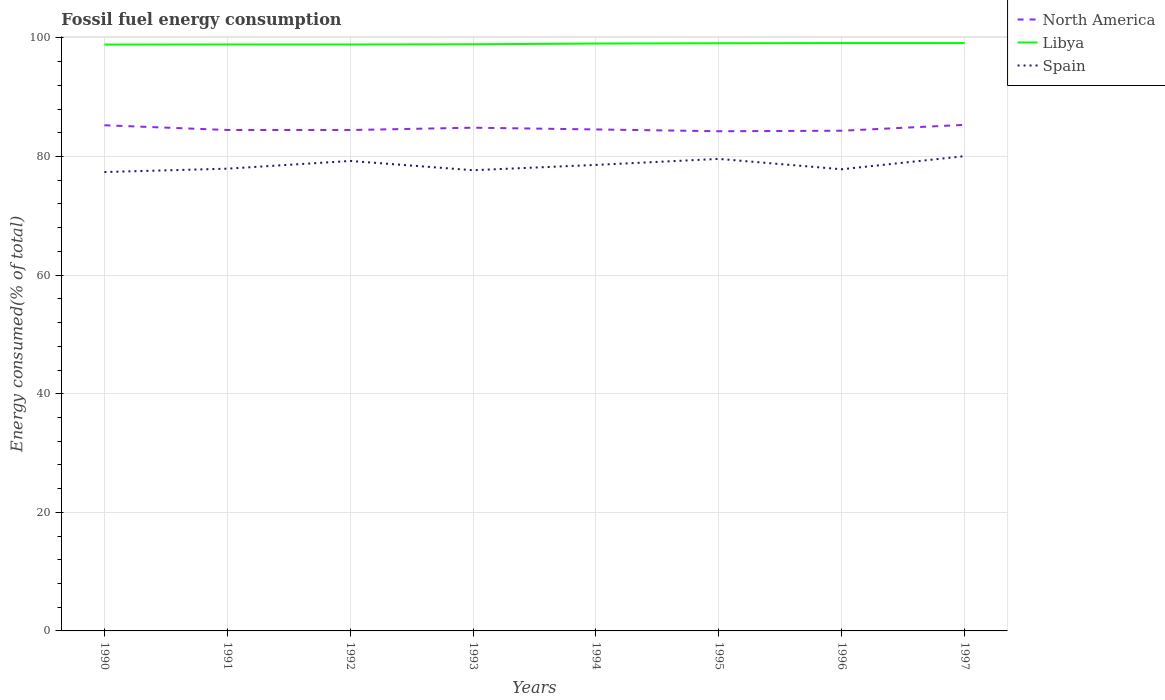How many different coloured lines are there?
Offer a very short reply. 3. Is the number of lines equal to the number of legend labels?
Offer a terse response. Yes. Across all years, what is the maximum percentage of energy consumed in Spain?
Give a very brief answer. 77.39. In which year was the percentage of energy consumed in Spain maximum?
Provide a short and direct response. 1990. What is the total percentage of energy consumed in Spain in the graph?
Keep it short and to the point. -0.9. What is the difference between the highest and the second highest percentage of energy consumed in Spain?
Your response must be concise. 2.67. What is the difference between the highest and the lowest percentage of energy consumed in Spain?
Make the answer very short. 4. What is the difference between two consecutive major ticks on the Y-axis?
Provide a succinct answer. 20. Are the values on the major ticks of Y-axis written in scientific E-notation?
Provide a short and direct response. No. Does the graph contain grids?
Ensure brevity in your answer.  Yes. What is the title of the graph?
Your answer should be very brief. Fossil fuel energy consumption. Does "Trinidad and Tobago" appear as one of the legend labels in the graph?
Provide a succinct answer. No. What is the label or title of the X-axis?
Give a very brief answer. Years. What is the label or title of the Y-axis?
Your answer should be very brief. Energy consumed(% of total). What is the Energy consumed(% of total) of North America in 1990?
Your response must be concise. 85.27. What is the Energy consumed(% of total) of Libya in 1990?
Give a very brief answer. 98.88. What is the Energy consumed(% of total) in Spain in 1990?
Provide a succinct answer. 77.39. What is the Energy consumed(% of total) of North America in 1991?
Give a very brief answer. 84.48. What is the Energy consumed(% of total) in Libya in 1991?
Your response must be concise. 98.9. What is the Energy consumed(% of total) of Spain in 1991?
Give a very brief answer. 77.95. What is the Energy consumed(% of total) in North America in 1992?
Offer a terse response. 84.47. What is the Energy consumed(% of total) in Libya in 1992?
Your response must be concise. 98.89. What is the Energy consumed(% of total) in Spain in 1992?
Your response must be concise. 79.25. What is the Energy consumed(% of total) in North America in 1993?
Keep it short and to the point. 84.86. What is the Energy consumed(% of total) in Libya in 1993?
Give a very brief answer. 98.93. What is the Energy consumed(% of total) in Spain in 1993?
Give a very brief answer. 77.69. What is the Energy consumed(% of total) in North America in 1994?
Offer a terse response. 84.57. What is the Energy consumed(% of total) of Libya in 1994?
Offer a terse response. 99.05. What is the Energy consumed(% of total) of Spain in 1994?
Your response must be concise. 78.59. What is the Energy consumed(% of total) of North America in 1995?
Your response must be concise. 84.27. What is the Energy consumed(% of total) of Libya in 1995?
Offer a terse response. 99.11. What is the Energy consumed(% of total) in Spain in 1995?
Make the answer very short. 79.6. What is the Energy consumed(% of total) in North America in 1996?
Provide a short and direct response. 84.35. What is the Energy consumed(% of total) of Libya in 1996?
Give a very brief answer. 99.14. What is the Energy consumed(% of total) in Spain in 1996?
Your response must be concise. 77.85. What is the Energy consumed(% of total) of North America in 1997?
Provide a short and direct response. 85.34. What is the Energy consumed(% of total) of Libya in 1997?
Offer a terse response. 99.14. What is the Energy consumed(% of total) in Spain in 1997?
Provide a short and direct response. 80.06. Across all years, what is the maximum Energy consumed(% of total) of North America?
Provide a succinct answer. 85.34. Across all years, what is the maximum Energy consumed(% of total) in Libya?
Ensure brevity in your answer.  99.14. Across all years, what is the maximum Energy consumed(% of total) of Spain?
Ensure brevity in your answer.  80.06. Across all years, what is the minimum Energy consumed(% of total) in North America?
Make the answer very short. 84.27. Across all years, what is the minimum Energy consumed(% of total) in Libya?
Provide a short and direct response. 98.88. Across all years, what is the minimum Energy consumed(% of total) of Spain?
Your response must be concise. 77.39. What is the total Energy consumed(% of total) of North America in the graph?
Provide a succinct answer. 677.61. What is the total Energy consumed(% of total) in Libya in the graph?
Your answer should be very brief. 792.04. What is the total Energy consumed(% of total) in Spain in the graph?
Make the answer very short. 628.39. What is the difference between the Energy consumed(% of total) in North America in 1990 and that in 1991?
Keep it short and to the point. 0.79. What is the difference between the Energy consumed(% of total) in Libya in 1990 and that in 1991?
Provide a succinct answer. -0.02. What is the difference between the Energy consumed(% of total) of Spain in 1990 and that in 1991?
Keep it short and to the point. -0.57. What is the difference between the Energy consumed(% of total) in North America in 1990 and that in 1992?
Provide a succinct answer. 0.8. What is the difference between the Energy consumed(% of total) of Libya in 1990 and that in 1992?
Keep it short and to the point. -0.01. What is the difference between the Energy consumed(% of total) of Spain in 1990 and that in 1992?
Offer a terse response. -1.87. What is the difference between the Energy consumed(% of total) in North America in 1990 and that in 1993?
Offer a terse response. 0.41. What is the difference between the Energy consumed(% of total) of Libya in 1990 and that in 1993?
Keep it short and to the point. -0.05. What is the difference between the Energy consumed(% of total) in Spain in 1990 and that in 1993?
Offer a very short reply. -0.31. What is the difference between the Energy consumed(% of total) of North America in 1990 and that in 1994?
Your response must be concise. 0.7. What is the difference between the Energy consumed(% of total) in Libya in 1990 and that in 1994?
Give a very brief answer. -0.17. What is the difference between the Energy consumed(% of total) in Spain in 1990 and that in 1994?
Provide a short and direct response. -1.2. What is the difference between the Energy consumed(% of total) of North America in 1990 and that in 1995?
Your answer should be very brief. 1.01. What is the difference between the Energy consumed(% of total) in Libya in 1990 and that in 1995?
Provide a short and direct response. -0.23. What is the difference between the Energy consumed(% of total) of Spain in 1990 and that in 1995?
Offer a terse response. -2.21. What is the difference between the Energy consumed(% of total) of North America in 1990 and that in 1996?
Your answer should be compact. 0.92. What is the difference between the Energy consumed(% of total) of Libya in 1990 and that in 1996?
Your response must be concise. -0.26. What is the difference between the Energy consumed(% of total) in Spain in 1990 and that in 1996?
Keep it short and to the point. -0.47. What is the difference between the Energy consumed(% of total) of North America in 1990 and that in 1997?
Provide a short and direct response. -0.07. What is the difference between the Energy consumed(% of total) of Libya in 1990 and that in 1997?
Keep it short and to the point. -0.26. What is the difference between the Energy consumed(% of total) in Spain in 1990 and that in 1997?
Keep it short and to the point. -2.67. What is the difference between the Energy consumed(% of total) in North America in 1991 and that in 1992?
Give a very brief answer. 0.01. What is the difference between the Energy consumed(% of total) of Libya in 1991 and that in 1992?
Your answer should be compact. 0.01. What is the difference between the Energy consumed(% of total) of Spain in 1991 and that in 1992?
Provide a succinct answer. -1.3. What is the difference between the Energy consumed(% of total) in North America in 1991 and that in 1993?
Ensure brevity in your answer.  -0.38. What is the difference between the Energy consumed(% of total) of Libya in 1991 and that in 1993?
Your answer should be compact. -0.03. What is the difference between the Energy consumed(% of total) of Spain in 1991 and that in 1993?
Offer a terse response. 0.26. What is the difference between the Energy consumed(% of total) in North America in 1991 and that in 1994?
Offer a terse response. -0.09. What is the difference between the Energy consumed(% of total) in Libya in 1991 and that in 1994?
Make the answer very short. -0.16. What is the difference between the Energy consumed(% of total) in Spain in 1991 and that in 1994?
Give a very brief answer. -0.64. What is the difference between the Energy consumed(% of total) in North America in 1991 and that in 1995?
Ensure brevity in your answer.  0.21. What is the difference between the Energy consumed(% of total) of Libya in 1991 and that in 1995?
Your answer should be very brief. -0.21. What is the difference between the Energy consumed(% of total) of Spain in 1991 and that in 1995?
Give a very brief answer. -1.65. What is the difference between the Energy consumed(% of total) in North America in 1991 and that in 1996?
Offer a terse response. 0.13. What is the difference between the Energy consumed(% of total) in Libya in 1991 and that in 1996?
Keep it short and to the point. -0.25. What is the difference between the Energy consumed(% of total) in Spain in 1991 and that in 1996?
Your response must be concise. 0.1. What is the difference between the Energy consumed(% of total) in North America in 1991 and that in 1997?
Keep it short and to the point. -0.86. What is the difference between the Energy consumed(% of total) of Libya in 1991 and that in 1997?
Your answer should be compact. -0.24. What is the difference between the Energy consumed(% of total) in Spain in 1991 and that in 1997?
Offer a terse response. -2.11. What is the difference between the Energy consumed(% of total) in North America in 1992 and that in 1993?
Ensure brevity in your answer.  -0.39. What is the difference between the Energy consumed(% of total) of Libya in 1992 and that in 1993?
Ensure brevity in your answer.  -0.04. What is the difference between the Energy consumed(% of total) in Spain in 1992 and that in 1993?
Provide a short and direct response. 1.56. What is the difference between the Energy consumed(% of total) of North America in 1992 and that in 1994?
Make the answer very short. -0.1. What is the difference between the Energy consumed(% of total) of Libya in 1992 and that in 1994?
Offer a very short reply. -0.16. What is the difference between the Energy consumed(% of total) in Spain in 1992 and that in 1994?
Your answer should be compact. 0.66. What is the difference between the Energy consumed(% of total) in North America in 1992 and that in 1995?
Offer a terse response. 0.2. What is the difference between the Energy consumed(% of total) of Libya in 1992 and that in 1995?
Ensure brevity in your answer.  -0.22. What is the difference between the Energy consumed(% of total) of Spain in 1992 and that in 1995?
Provide a short and direct response. -0.35. What is the difference between the Energy consumed(% of total) of North America in 1992 and that in 1996?
Make the answer very short. 0.12. What is the difference between the Energy consumed(% of total) of Libya in 1992 and that in 1996?
Your answer should be very brief. -0.25. What is the difference between the Energy consumed(% of total) of Spain in 1992 and that in 1996?
Your response must be concise. 1.4. What is the difference between the Energy consumed(% of total) in North America in 1992 and that in 1997?
Offer a terse response. -0.87. What is the difference between the Energy consumed(% of total) of Libya in 1992 and that in 1997?
Offer a terse response. -0.25. What is the difference between the Energy consumed(% of total) of Spain in 1992 and that in 1997?
Make the answer very short. -0.81. What is the difference between the Energy consumed(% of total) in North America in 1993 and that in 1994?
Make the answer very short. 0.29. What is the difference between the Energy consumed(% of total) of Libya in 1993 and that in 1994?
Your response must be concise. -0.12. What is the difference between the Energy consumed(% of total) in Spain in 1993 and that in 1994?
Ensure brevity in your answer.  -0.9. What is the difference between the Energy consumed(% of total) of North America in 1993 and that in 1995?
Your answer should be very brief. 0.6. What is the difference between the Energy consumed(% of total) in Libya in 1993 and that in 1995?
Your answer should be very brief. -0.17. What is the difference between the Energy consumed(% of total) of Spain in 1993 and that in 1995?
Give a very brief answer. -1.91. What is the difference between the Energy consumed(% of total) in North America in 1993 and that in 1996?
Offer a terse response. 0.51. What is the difference between the Energy consumed(% of total) in Libya in 1993 and that in 1996?
Your answer should be very brief. -0.21. What is the difference between the Energy consumed(% of total) in Spain in 1993 and that in 1996?
Keep it short and to the point. -0.16. What is the difference between the Energy consumed(% of total) in North America in 1993 and that in 1997?
Make the answer very short. -0.48. What is the difference between the Energy consumed(% of total) in Libya in 1993 and that in 1997?
Provide a succinct answer. -0.21. What is the difference between the Energy consumed(% of total) in Spain in 1993 and that in 1997?
Your answer should be very brief. -2.37. What is the difference between the Energy consumed(% of total) in North America in 1994 and that in 1995?
Keep it short and to the point. 0.3. What is the difference between the Energy consumed(% of total) in Libya in 1994 and that in 1995?
Offer a terse response. -0.05. What is the difference between the Energy consumed(% of total) of Spain in 1994 and that in 1995?
Provide a short and direct response. -1.01. What is the difference between the Energy consumed(% of total) in North America in 1994 and that in 1996?
Give a very brief answer. 0.22. What is the difference between the Energy consumed(% of total) in Libya in 1994 and that in 1996?
Provide a short and direct response. -0.09. What is the difference between the Energy consumed(% of total) of Spain in 1994 and that in 1996?
Offer a terse response. 0.74. What is the difference between the Energy consumed(% of total) of North America in 1994 and that in 1997?
Make the answer very short. -0.77. What is the difference between the Energy consumed(% of total) of Libya in 1994 and that in 1997?
Your answer should be very brief. -0.08. What is the difference between the Energy consumed(% of total) of Spain in 1994 and that in 1997?
Give a very brief answer. -1.47. What is the difference between the Energy consumed(% of total) in North America in 1995 and that in 1996?
Offer a terse response. -0.08. What is the difference between the Energy consumed(% of total) of Libya in 1995 and that in 1996?
Offer a very short reply. -0.04. What is the difference between the Energy consumed(% of total) in Spain in 1995 and that in 1996?
Make the answer very short. 1.75. What is the difference between the Energy consumed(% of total) of North America in 1995 and that in 1997?
Your answer should be compact. -1.08. What is the difference between the Energy consumed(% of total) in Libya in 1995 and that in 1997?
Ensure brevity in your answer.  -0.03. What is the difference between the Energy consumed(% of total) in Spain in 1995 and that in 1997?
Your answer should be very brief. -0.46. What is the difference between the Energy consumed(% of total) of North America in 1996 and that in 1997?
Keep it short and to the point. -0.99. What is the difference between the Energy consumed(% of total) of Libya in 1996 and that in 1997?
Provide a short and direct response. 0. What is the difference between the Energy consumed(% of total) in Spain in 1996 and that in 1997?
Offer a terse response. -2.21. What is the difference between the Energy consumed(% of total) of North America in 1990 and the Energy consumed(% of total) of Libya in 1991?
Provide a succinct answer. -13.62. What is the difference between the Energy consumed(% of total) of North America in 1990 and the Energy consumed(% of total) of Spain in 1991?
Offer a terse response. 7.32. What is the difference between the Energy consumed(% of total) of Libya in 1990 and the Energy consumed(% of total) of Spain in 1991?
Keep it short and to the point. 20.93. What is the difference between the Energy consumed(% of total) of North America in 1990 and the Energy consumed(% of total) of Libya in 1992?
Ensure brevity in your answer.  -13.62. What is the difference between the Energy consumed(% of total) of North America in 1990 and the Energy consumed(% of total) of Spain in 1992?
Provide a short and direct response. 6.02. What is the difference between the Energy consumed(% of total) of Libya in 1990 and the Energy consumed(% of total) of Spain in 1992?
Keep it short and to the point. 19.63. What is the difference between the Energy consumed(% of total) in North America in 1990 and the Energy consumed(% of total) in Libya in 1993?
Provide a succinct answer. -13.66. What is the difference between the Energy consumed(% of total) of North America in 1990 and the Energy consumed(% of total) of Spain in 1993?
Provide a succinct answer. 7.58. What is the difference between the Energy consumed(% of total) of Libya in 1990 and the Energy consumed(% of total) of Spain in 1993?
Provide a short and direct response. 21.19. What is the difference between the Energy consumed(% of total) in North America in 1990 and the Energy consumed(% of total) in Libya in 1994?
Your answer should be very brief. -13.78. What is the difference between the Energy consumed(% of total) in North America in 1990 and the Energy consumed(% of total) in Spain in 1994?
Make the answer very short. 6.68. What is the difference between the Energy consumed(% of total) of Libya in 1990 and the Energy consumed(% of total) of Spain in 1994?
Provide a succinct answer. 20.29. What is the difference between the Energy consumed(% of total) in North America in 1990 and the Energy consumed(% of total) in Libya in 1995?
Your response must be concise. -13.83. What is the difference between the Energy consumed(% of total) in North America in 1990 and the Energy consumed(% of total) in Spain in 1995?
Offer a terse response. 5.67. What is the difference between the Energy consumed(% of total) in Libya in 1990 and the Energy consumed(% of total) in Spain in 1995?
Provide a short and direct response. 19.28. What is the difference between the Energy consumed(% of total) of North America in 1990 and the Energy consumed(% of total) of Libya in 1996?
Provide a succinct answer. -13.87. What is the difference between the Energy consumed(% of total) in North America in 1990 and the Energy consumed(% of total) in Spain in 1996?
Offer a terse response. 7.42. What is the difference between the Energy consumed(% of total) of Libya in 1990 and the Energy consumed(% of total) of Spain in 1996?
Your answer should be compact. 21.03. What is the difference between the Energy consumed(% of total) in North America in 1990 and the Energy consumed(% of total) in Libya in 1997?
Your answer should be very brief. -13.87. What is the difference between the Energy consumed(% of total) in North America in 1990 and the Energy consumed(% of total) in Spain in 1997?
Your answer should be very brief. 5.21. What is the difference between the Energy consumed(% of total) of Libya in 1990 and the Energy consumed(% of total) of Spain in 1997?
Your answer should be compact. 18.82. What is the difference between the Energy consumed(% of total) in North America in 1991 and the Energy consumed(% of total) in Libya in 1992?
Make the answer very short. -14.41. What is the difference between the Energy consumed(% of total) of North America in 1991 and the Energy consumed(% of total) of Spain in 1992?
Give a very brief answer. 5.22. What is the difference between the Energy consumed(% of total) of Libya in 1991 and the Energy consumed(% of total) of Spain in 1992?
Ensure brevity in your answer.  19.64. What is the difference between the Energy consumed(% of total) in North America in 1991 and the Energy consumed(% of total) in Libya in 1993?
Ensure brevity in your answer.  -14.45. What is the difference between the Energy consumed(% of total) of North America in 1991 and the Energy consumed(% of total) of Spain in 1993?
Your answer should be very brief. 6.79. What is the difference between the Energy consumed(% of total) in Libya in 1991 and the Energy consumed(% of total) in Spain in 1993?
Give a very brief answer. 21.2. What is the difference between the Energy consumed(% of total) in North America in 1991 and the Energy consumed(% of total) in Libya in 1994?
Provide a short and direct response. -14.57. What is the difference between the Energy consumed(% of total) in North America in 1991 and the Energy consumed(% of total) in Spain in 1994?
Provide a short and direct response. 5.89. What is the difference between the Energy consumed(% of total) in Libya in 1991 and the Energy consumed(% of total) in Spain in 1994?
Your response must be concise. 20.31. What is the difference between the Energy consumed(% of total) of North America in 1991 and the Energy consumed(% of total) of Libya in 1995?
Provide a succinct answer. -14.63. What is the difference between the Energy consumed(% of total) of North America in 1991 and the Energy consumed(% of total) of Spain in 1995?
Make the answer very short. 4.88. What is the difference between the Energy consumed(% of total) in Libya in 1991 and the Energy consumed(% of total) in Spain in 1995?
Offer a terse response. 19.3. What is the difference between the Energy consumed(% of total) in North America in 1991 and the Energy consumed(% of total) in Libya in 1996?
Make the answer very short. -14.66. What is the difference between the Energy consumed(% of total) in North America in 1991 and the Energy consumed(% of total) in Spain in 1996?
Your response must be concise. 6.63. What is the difference between the Energy consumed(% of total) in Libya in 1991 and the Energy consumed(% of total) in Spain in 1996?
Make the answer very short. 21.04. What is the difference between the Energy consumed(% of total) of North America in 1991 and the Energy consumed(% of total) of Libya in 1997?
Give a very brief answer. -14.66. What is the difference between the Energy consumed(% of total) of North America in 1991 and the Energy consumed(% of total) of Spain in 1997?
Your answer should be compact. 4.42. What is the difference between the Energy consumed(% of total) of Libya in 1991 and the Energy consumed(% of total) of Spain in 1997?
Give a very brief answer. 18.84. What is the difference between the Energy consumed(% of total) in North America in 1992 and the Energy consumed(% of total) in Libya in 1993?
Your answer should be very brief. -14.46. What is the difference between the Energy consumed(% of total) of North America in 1992 and the Energy consumed(% of total) of Spain in 1993?
Your answer should be very brief. 6.78. What is the difference between the Energy consumed(% of total) in Libya in 1992 and the Energy consumed(% of total) in Spain in 1993?
Offer a very short reply. 21.2. What is the difference between the Energy consumed(% of total) of North America in 1992 and the Energy consumed(% of total) of Libya in 1994?
Make the answer very short. -14.58. What is the difference between the Energy consumed(% of total) of North America in 1992 and the Energy consumed(% of total) of Spain in 1994?
Your answer should be compact. 5.88. What is the difference between the Energy consumed(% of total) of Libya in 1992 and the Energy consumed(% of total) of Spain in 1994?
Provide a short and direct response. 20.3. What is the difference between the Energy consumed(% of total) of North America in 1992 and the Energy consumed(% of total) of Libya in 1995?
Make the answer very short. -14.64. What is the difference between the Energy consumed(% of total) in North America in 1992 and the Energy consumed(% of total) in Spain in 1995?
Your answer should be very brief. 4.87. What is the difference between the Energy consumed(% of total) of Libya in 1992 and the Energy consumed(% of total) of Spain in 1995?
Make the answer very short. 19.29. What is the difference between the Energy consumed(% of total) in North America in 1992 and the Energy consumed(% of total) in Libya in 1996?
Offer a terse response. -14.67. What is the difference between the Energy consumed(% of total) of North America in 1992 and the Energy consumed(% of total) of Spain in 1996?
Provide a succinct answer. 6.62. What is the difference between the Energy consumed(% of total) in Libya in 1992 and the Energy consumed(% of total) in Spain in 1996?
Your response must be concise. 21.04. What is the difference between the Energy consumed(% of total) of North America in 1992 and the Energy consumed(% of total) of Libya in 1997?
Provide a succinct answer. -14.67. What is the difference between the Energy consumed(% of total) of North America in 1992 and the Energy consumed(% of total) of Spain in 1997?
Your response must be concise. 4.41. What is the difference between the Energy consumed(% of total) of Libya in 1992 and the Energy consumed(% of total) of Spain in 1997?
Keep it short and to the point. 18.83. What is the difference between the Energy consumed(% of total) in North America in 1993 and the Energy consumed(% of total) in Libya in 1994?
Make the answer very short. -14.19. What is the difference between the Energy consumed(% of total) in North America in 1993 and the Energy consumed(% of total) in Spain in 1994?
Provide a short and direct response. 6.27. What is the difference between the Energy consumed(% of total) of Libya in 1993 and the Energy consumed(% of total) of Spain in 1994?
Provide a succinct answer. 20.34. What is the difference between the Energy consumed(% of total) in North America in 1993 and the Energy consumed(% of total) in Libya in 1995?
Your answer should be compact. -14.24. What is the difference between the Energy consumed(% of total) in North America in 1993 and the Energy consumed(% of total) in Spain in 1995?
Make the answer very short. 5.26. What is the difference between the Energy consumed(% of total) of Libya in 1993 and the Energy consumed(% of total) of Spain in 1995?
Provide a short and direct response. 19.33. What is the difference between the Energy consumed(% of total) of North America in 1993 and the Energy consumed(% of total) of Libya in 1996?
Provide a succinct answer. -14.28. What is the difference between the Energy consumed(% of total) in North America in 1993 and the Energy consumed(% of total) in Spain in 1996?
Your response must be concise. 7.01. What is the difference between the Energy consumed(% of total) of Libya in 1993 and the Energy consumed(% of total) of Spain in 1996?
Keep it short and to the point. 21.08. What is the difference between the Energy consumed(% of total) of North America in 1993 and the Energy consumed(% of total) of Libya in 1997?
Your answer should be compact. -14.28. What is the difference between the Energy consumed(% of total) of North America in 1993 and the Energy consumed(% of total) of Spain in 1997?
Provide a short and direct response. 4.8. What is the difference between the Energy consumed(% of total) in Libya in 1993 and the Energy consumed(% of total) in Spain in 1997?
Provide a short and direct response. 18.87. What is the difference between the Energy consumed(% of total) in North America in 1994 and the Energy consumed(% of total) in Libya in 1995?
Give a very brief answer. -14.54. What is the difference between the Energy consumed(% of total) in North America in 1994 and the Energy consumed(% of total) in Spain in 1995?
Provide a succinct answer. 4.97. What is the difference between the Energy consumed(% of total) of Libya in 1994 and the Energy consumed(% of total) of Spain in 1995?
Offer a terse response. 19.45. What is the difference between the Energy consumed(% of total) in North America in 1994 and the Energy consumed(% of total) in Libya in 1996?
Your answer should be very brief. -14.57. What is the difference between the Energy consumed(% of total) in North America in 1994 and the Energy consumed(% of total) in Spain in 1996?
Ensure brevity in your answer.  6.72. What is the difference between the Energy consumed(% of total) of Libya in 1994 and the Energy consumed(% of total) of Spain in 1996?
Ensure brevity in your answer.  21.2. What is the difference between the Energy consumed(% of total) in North America in 1994 and the Energy consumed(% of total) in Libya in 1997?
Your answer should be very brief. -14.57. What is the difference between the Energy consumed(% of total) in North America in 1994 and the Energy consumed(% of total) in Spain in 1997?
Your answer should be compact. 4.51. What is the difference between the Energy consumed(% of total) of Libya in 1994 and the Energy consumed(% of total) of Spain in 1997?
Provide a succinct answer. 18.99. What is the difference between the Energy consumed(% of total) of North America in 1995 and the Energy consumed(% of total) of Libya in 1996?
Your answer should be very brief. -14.88. What is the difference between the Energy consumed(% of total) in North America in 1995 and the Energy consumed(% of total) in Spain in 1996?
Offer a very short reply. 6.41. What is the difference between the Energy consumed(% of total) of Libya in 1995 and the Energy consumed(% of total) of Spain in 1996?
Provide a short and direct response. 21.25. What is the difference between the Energy consumed(% of total) of North America in 1995 and the Energy consumed(% of total) of Libya in 1997?
Keep it short and to the point. -14.87. What is the difference between the Energy consumed(% of total) of North America in 1995 and the Energy consumed(% of total) of Spain in 1997?
Ensure brevity in your answer.  4.2. What is the difference between the Energy consumed(% of total) in Libya in 1995 and the Energy consumed(% of total) in Spain in 1997?
Make the answer very short. 19.04. What is the difference between the Energy consumed(% of total) in North America in 1996 and the Energy consumed(% of total) in Libya in 1997?
Your answer should be very brief. -14.79. What is the difference between the Energy consumed(% of total) in North America in 1996 and the Energy consumed(% of total) in Spain in 1997?
Ensure brevity in your answer.  4.29. What is the difference between the Energy consumed(% of total) in Libya in 1996 and the Energy consumed(% of total) in Spain in 1997?
Your response must be concise. 19.08. What is the average Energy consumed(% of total) in North America per year?
Ensure brevity in your answer.  84.7. What is the average Energy consumed(% of total) in Libya per year?
Give a very brief answer. 99. What is the average Energy consumed(% of total) of Spain per year?
Provide a succinct answer. 78.55. In the year 1990, what is the difference between the Energy consumed(% of total) in North America and Energy consumed(% of total) in Libya?
Provide a short and direct response. -13.61. In the year 1990, what is the difference between the Energy consumed(% of total) in North America and Energy consumed(% of total) in Spain?
Make the answer very short. 7.89. In the year 1990, what is the difference between the Energy consumed(% of total) in Libya and Energy consumed(% of total) in Spain?
Your response must be concise. 21.49. In the year 1991, what is the difference between the Energy consumed(% of total) of North America and Energy consumed(% of total) of Libya?
Your answer should be compact. -14.42. In the year 1991, what is the difference between the Energy consumed(% of total) of North America and Energy consumed(% of total) of Spain?
Offer a very short reply. 6.53. In the year 1991, what is the difference between the Energy consumed(% of total) of Libya and Energy consumed(% of total) of Spain?
Ensure brevity in your answer.  20.94. In the year 1992, what is the difference between the Energy consumed(% of total) in North America and Energy consumed(% of total) in Libya?
Ensure brevity in your answer.  -14.42. In the year 1992, what is the difference between the Energy consumed(% of total) in North America and Energy consumed(% of total) in Spain?
Offer a very short reply. 5.22. In the year 1992, what is the difference between the Energy consumed(% of total) of Libya and Energy consumed(% of total) of Spain?
Ensure brevity in your answer.  19.64. In the year 1993, what is the difference between the Energy consumed(% of total) of North America and Energy consumed(% of total) of Libya?
Keep it short and to the point. -14.07. In the year 1993, what is the difference between the Energy consumed(% of total) of North America and Energy consumed(% of total) of Spain?
Your answer should be very brief. 7.17. In the year 1993, what is the difference between the Energy consumed(% of total) of Libya and Energy consumed(% of total) of Spain?
Offer a terse response. 21.24. In the year 1994, what is the difference between the Energy consumed(% of total) in North America and Energy consumed(% of total) in Libya?
Provide a short and direct response. -14.48. In the year 1994, what is the difference between the Energy consumed(% of total) in North America and Energy consumed(% of total) in Spain?
Your answer should be compact. 5.98. In the year 1994, what is the difference between the Energy consumed(% of total) of Libya and Energy consumed(% of total) of Spain?
Offer a very short reply. 20.46. In the year 1995, what is the difference between the Energy consumed(% of total) of North America and Energy consumed(% of total) of Libya?
Make the answer very short. -14.84. In the year 1995, what is the difference between the Energy consumed(% of total) in North America and Energy consumed(% of total) in Spain?
Offer a very short reply. 4.67. In the year 1995, what is the difference between the Energy consumed(% of total) of Libya and Energy consumed(% of total) of Spain?
Ensure brevity in your answer.  19.51. In the year 1996, what is the difference between the Energy consumed(% of total) in North America and Energy consumed(% of total) in Libya?
Your answer should be very brief. -14.79. In the year 1996, what is the difference between the Energy consumed(% of total) in North America and Energy consumed(% of total) in Spain?
Give a very brief answer. 6.5. In the year 1996, what is the difference between the Energy consumed(% of total) of Libya and Energy consumed(% of total) of Spain?
Your response must be concise. 21.29. In the year 1997, what is the difference between the Energy consumed(% of total) of North America and Energy consumed(% of total) of Libya?
Give a very brief answer. -13.8. In the year 1997, what is the difference between the Energy consumed(% of total) of North America and Energy consumed(% of total) of Spain?
Your response must be concise. 5.28. In the year 1997, what is the difference between the Energy consumed(% of total) of Libya and Energy consumed(% of total) of Spain?
Make the answer very short. 19.08. What is the ratio of the Energy consumed(% of total) in North America in 1990 to that in 1991?
Ensure brevity in your answer.  1.01. What is the ratio of the Energy consumed(% of total) of North America in 1990 to that in 1992?
Ensure brevity in your answer.  1.01. What is the ratio of the Energy consumed(% of total) in Spain in 1990 to that in 1992?
Provide a short and direct response. 0.98. What is the ratio of the Energy consumed(% of total) of Spain in 1990 to that in 1993?
Provide a short and direct response. 1. What is the ratio of the Energy consumed(% of total) of North America in 1990 to that in 1994?
Provide a short and direct response. 1.01. What is the ratio of the Energy consumed(% of total) of Spain in 1990 to that in 1994?
Make the answer very short. 0.98. What is the ratio of the Energy consumed(% of total) in North America in 1990 to that in 1995?
Your answer should be very brief. 1.01. What is the ratio of the Energy consumed(% of total) of Libya in 1990 to that in 1995?
Provide a short and direct response. 1. What is the ratio of the Energy consumed(% of total) of Spain in 1990 to that in 1995?
Give a very brief answer. 0.97. What is the ratio of the Energy consumed(% of total) of North America in 1990 to that in 1996?
Provide a succinct answer. 1.01. What is the ratio of the Energy consumed(% of total) in Libya in 1990 to that in 1996?
Ensure brevity in your answer.  1. What is the ratio of the Energy consumed(% of total) in Spain in 1990 to that in 1996?
Make the answer very short. 0.99. What is the ratio of the Energy consumed(% of total) of Spain in 1990 to that in 1997?
Your response must be concise. 0.97. What is the ratio of the Energy consumed(% of total) in Libya in 1991 to that in 1992?
Give a very brief answer. 1. What is the ratio of the Energy consumed(% of total) of Spain in 1991 to that in 1992?
Keep it short and to the point. 0.98. What is the ratio of the Energy consumed(% of total) of North America in 1991 to that in 1993?
Give a very brief answer. 1. What is the ratio of the Energy consumed(% of total) of Libya in 1991 to that in 1993?
Offer a very short reply. 1. What is the ratio of the Energy consumed(% of total) in Spain in 1991 to that in 1995?
Your answer should be compact. 0.98. What is the ratio of the Energy consumed(% of total) of Libya in 1991 to that in 1996?
Your answer should be very brief. 1. What is the ratio of the Energy consumed(% of total) in Libya in 1991 to that in 1997?
Ensure brevity in your answer.  1. What is the ratio of the Energy consumed(% of total) in Spain in 1991 to that in 1997?
Provide a succinct answer. 0.97. What is the ratio of the Energy consumed(% of total) in Libya in 1992 to that in 1993?
Make the answer very short. 1. What is the ratio of the Energy consumed(% of total) in Spain in 1992 to that in 1993?
Your answer should be compact. 1.02. What is the ratio of the Energy consumed(% of total) in Libya in 1992 to that in 1994?
Give a very brief answer. 1. What is the ratio of the Energy consumed(% of total) in Spain in 1992 to that in 1994?
Ensure brevity in your answer.  1.01. What is the ratio of the Energy consumed(% of total) in North America in 1992 to that in 1995?
Your answer should be compact. 1. What is the ratio of the Energy consumed(% of total) of North America in 1992 to that in 1996?
Offer a terse response. 1. What is the ratio of the Energy consumed(% of total) in Libya in 1992 to that in 1996?
Keep it short and to the point. 1. What is the ratio of the Energy consumed(% of total) of North America in 1992 to that in 1997?
Offer a very short reply. 0.99. What is the ratio of the Energy consumed(% of total) in Libya in 1993 to that in 1994?
Make the answer very short. 1. What is the ratio of the Energy consumed(% of total) of North America in 1993 to that in 1995?
Offer a terse response. 1.01. What is the ratio of the Energy consumed(% of total) of Spain in 1993 to that in 1995?
Offer a very short reply. 0.98. What is the ratio of the Energy consumed(% of total) in North America in 1993 to that in 1997?
Give a very brief answer. 0.99. What is the ratio of the Energy consumed(% of total) of Libya in 1993 to that in 1997?
Give a very brief answer. 1. What is the ratio of the Energy consumed(% of total) in Spain in 1993 to that in 1997?
Keep it short and to the point. 0.97. What is the ratio of the Energy consumed(% of total) in Libya in 1994 to that in 1995?
Your answer should be very brief. 1. What is the ratio of the Energy consumed(% of total) in Spain in 1994 to that in 1995?
Make the answer very short. 0.99. What is the ratio of the Energy consumed(% of total) of North America in 1994 to that in 1996?
Your answer should be very brief. 1. What is the ratio of the Energy consumed(% of total) in Spain in 1994 to that in 1996?
Your response must be concise. 1.01. What is the ratio of the Energy consumed(% of total) of North America in 1994 to that in 1997?
Offer a terse response. 0.99. What is the ratio of the Energy consumed(% of total) of Spain in 1994 to that in 1997?
Provide a succinct answer. 0.98. What is the ratio of the Energy consumed(% of total) of North America in 1995 to that in 1996?
Make the answer very short. 1. What is the ratio of the Energy consumed(% of total) of Spain in 1995 to that in 1996?
Provide a short and direct response. 1.02. What is the ratio of the Energy consumed(% of total) of North America in 1995 to that in 1997?
Provide a succinct answer. 0.99. What is the ratio of the Energy consumed(% of total) of North America in 1996 to that in 1997?
Give a very brief answer. 0.99. What is the ratio of the Energy consumed(% of total) in Spain in 1996 to that in 1997?
Your response must be concise. 0.97. What is the difference between the highest and the second highest Energy consumed(% of total) in North America?
Keep it short and to the point. 0.07. What is the difference between the highest and the second highest Energy consumed(% of total) in Libya?
Offer a terse response. 0. What is the difference between the highest and the second highest Energy consumed(% of total) in Spain?
Offer a terse response. 0.46. What is the difference between the highest and the lowest Energy consumed(% of total) in North America?
Keep it short and to the point. 1.08. What is the difference between the highest and the lowest Energy consumed(% of total) of Libya?
Ensure brevity in your answer.  0.26. What is the difference between the highest and the lowest Energy consumed(% of total) in Spain?
Make the answer very short. 2.67. 